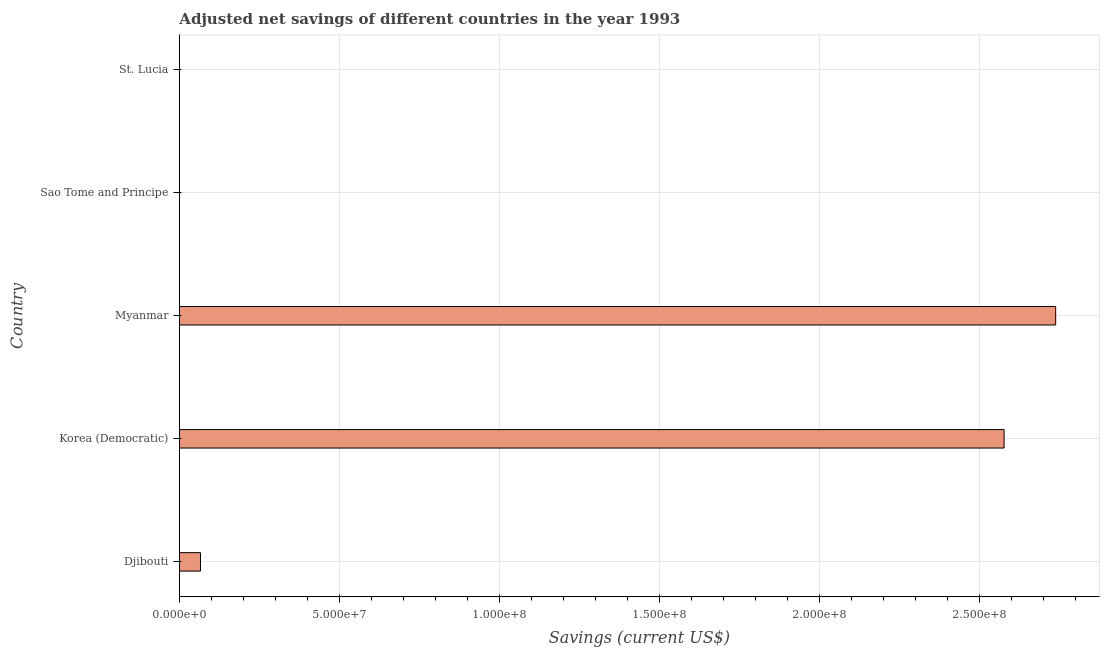Does the graph contain any zero values?
Offer a terse response. No. What is the title of the graph?
Your response must be concise. Adjusted net savings of different countries in the year 1993. What is the label or title of the X-axis?
Make the answer very short. Savings (current US$). What is the label or title of the Y-axis?
Provide a succinct answer. Country. What is the adjusted net savings in St. Lucia?
Provide a succinct answer. 1.04e+04. Across all countries, what is the maximum adjusted net savings?
Your response must be concise. 2.74e+08. Across all countries, what is the minimum adjusted net savings?
Provide a short and direct response. 5698.23. In which country was the adjusted net savings maximum?
Your answer should be very brief. Myanmar. In which country was the adjusted net savings minimum?
Your answer should be very brief. Sao Tome and Principe. What is the sum of the adjusted net savings?
Ensure brevity in your answer.  5.38e+08. What is the difference between the adjusted net savings in Djibouti and Myanmar?
Ensure brevity in your answer.  -2.67e+08. What is the average adjusted net savings per country?
Keep it short and to the point. 1.08e+08. What is the median adjusted net savings?
Keep it short and to the point. 6.58e+06. In how many countries, is the adjusted net savings greater than 10000000 US$?
Your response must be concise. 2. What is the ratio of the adjusted net savings in Sao Tome and Principe to that in St. Lucia?
Your answer should be compact. 0.55. Is the adjusted net savings in Sao Tome and Principe less than that in St. Lucia?
Offer a very short reply. Yes. Is the difference between the adjusted net savings in Korea (Democratic) and Sao Tome and Principe greater than the difference between any two countries?
Ensure brevity in your answer.  No. What is the difference between the highest and the second highest adjusted net savings?
Your answer should be very brief. 1.61e+07. What is the difference between the highest and the lowest adjusted net savings?
Give a very brief answer. 2.74e+08. In how many countries, is the adjusted net savings greater than the average adjusted net savings taken over all countries?
Give a very brief answer. 2. How many bars are there?
Give a very brief answer. 5. How many countries are there in the graph?
Give a very brief answer. 5. What is the difference between two consecutive major ticks on the X-axis?
Offer a very short reply. 5.00e+07. What is the Savings (current US$) in Djibouti?
Give a very brief answer. 6.58e+06. What is the Savings (current US$) of Korea (Democratic)?
Provide a succinct answer. 2.58e+08. What is the Savings (current US$) in Myanmar?
Provide a succinct answer. 2.74e+08. What is the Savings (current US$) in Sao Tome and Principe?
Provide a succinct answer. 5698.23. What is the Savings (current US$) of St. Lucia?
Make the answer very short. 1.04e+04. What is the difference between the Savings (current US$) in Djibouti and Korea (Democratic)?
Your answer should be very brief. -2.51e+08. What is the difference between the Savings (current US$) in Djibouti and Myanmar?
Provide a short and direct response. -2.67e+08. What is the difference between the Savings (current US$) in Djibouti and Sao Tome and Principe?
Your answer should be compact. 6.58e+06. What is the difference between the Savings (current US$) in Djibouti and St. Lucia?
Give a very brief answer. 6.57e+06. What is the difference between the Savings (current US$) in Korea (Democratic) and Myanmar?
Your answer should be compact. -1.61e+07. What is the difference between the Savings (current US$) in Korea (Democratic) and Sao Tome and Principe?
Give a very brief answer. 2.58e+08. What is the difference between the Savings (current US$) in Korea (Democratic) and St. Lucia?
Your answer should be compact. 2.58e+08. What is the difference between the Savings (current US$) in Myanmar and Sao Tome and Principe?
Keep it short and to the point. 2.74e+08. What is the difference between the Savings (current US$) in Myanmar and St. Lucia?
Provide a succinct answer. 2.74e+08. What is the difference between the Savings (current US$) in Sao Tome and Principe and St. Lucia?
Ensure brevity in your answer.  -4706.27. What is the ratio of the Savings (current US$) in Djibouti to that in Korea (Democratic)?
Keep it short and to the point. 0.03. What is the ratio of the Savings (current US$) in Djibouti to that in Myanmar?
Your response must be concise. 0.02. What is the ratio of the Savings (current US$) in Djibouti to that in Sao Tome and Principe?
Offer a very short reply. 1155.02. What is the ratio of the Savings (current US$) in Djibouti to that in St. Lucia?
Provide a short and direct response. 632.57. What is the ratio of the Savings (current US$) in Korea (Democratic) to that in Myanmar?
Your response must be concise. 0.94. What is the ratio of the Savings (current US$) in Korea (Democratic) to that in Sao Tome and Principe?
Your response must be concise. 4.52e+04. What is the ratio of the Savings (current US$) in Korea (Democratic) to that in St. Lucia?
Provide a short and direct response. 2.48e+04. What is the ratio of the Savings (current US$) in Myanmar to that in Sao Tome and Principe?
Offer a very short reply. 4.81e+04. What is the ratio of the Savings (current US$) in Myanmar to that in St. Lucia?
Provide a short and direct response. 2.63e+04. What is the ratio of the Savings (current US$) in Sao Tome and Principe to that in St. Lucia?
Your response must be concise. 0.55. 